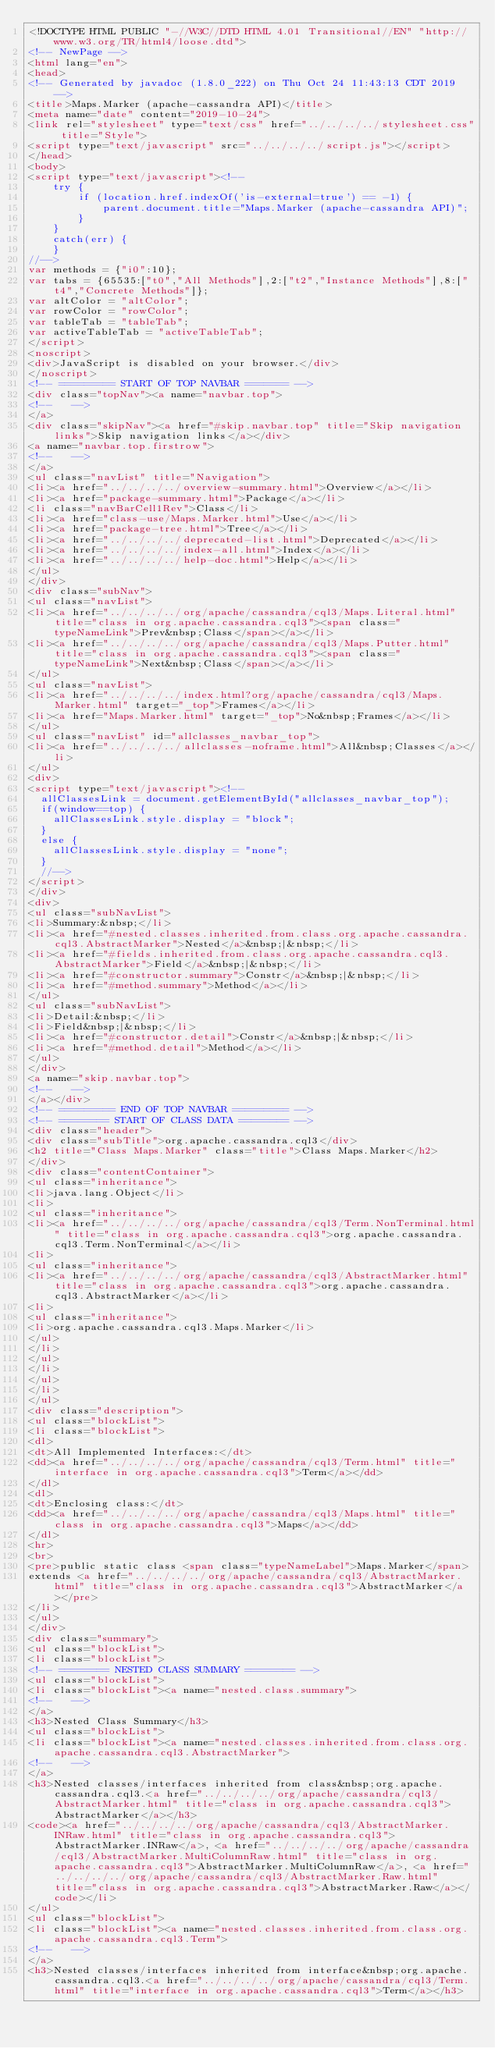Convert code to text. <code><loc_0><loc_0><loc_500><loc_500><_HTML_><!DOCTYPE HTML PUBLIC "-//W3C//DTD HTML 4.01 Transitional//EN" "http://www.w3.org/TR/html4/loose.dtd">
<!-- NewPage -->
<html lang="en">
<head>
<!-- Generated by javadoc (1.8.0_222) on Thu Oct 24 11:43:13 CDT 2019 -->
<title>Maps.Marker (apache-cassandra API)</title>
<meta name="date" content="2019-10-24">
<link rel="stylesheet" type="text/css" href="../../../../stylesheet.css" title="Style">
<script type="text/javascript" src="../../../../script.js"></script>
</head>
<body>
<script type="text/javascript"><!--
    try {
        if (location.href.indexOf('is-external=true') == -1) {
            parent.document.title="Maps.Marker (apache-cassandra API)";
        }
    }
    catch(err) {
    }
//-->
var methods = {"i0":10};
var tabs = {65535:["t0","All Methods"],2:["t2","Instance Methods"],8:["t4","Concrete Methods"]};
var altColor = "altColor";
var rowColor = "rowColor";
var tableTab = "tableTab";
var activeTableTab = "activeTableTab";
</script>
<noscript>
<div>JavaScript is disabled on your browser.</div>
</noscript>
<!-- ========= START OF TOP NAVBAR ======= -->
<div class="topNav"><a name="navbar.top">
<!--   -->
</a>
<div class="skipNav"><a href="#skip.navbar.top" title="Skip navigation links">Skip navigation links</a></div>
<a name="navbar.top.firstrow">
<!--   -->
</a>
<ul class="navList" title="Navigation">
<li><a href="../../../../overview-summary.html">Overview</a></li>
<li><a href="package-summary.html">Package</a></li>
<li class="navBarCell1Rev">Class</li>
<li><a href="class-use/Maps.Marker.html">Use</a></li>
<li><a href="package-tree.html">Tree</a></li>
<li><a href="../../../../deprecated-list.html">Deprecated</a></li>
<li><a href="../../../../index-all.html">Index</a></li>
<li><a href="../../../../help-doc.html">Help</a></li>
</ul>
</div>
<div class="subNav">
<ul class="navList">
<li><a href="../../../../org/apache/cassandra/cql3/Maps.Literal.html" title="class in org.apache.cassandra.cql3"><span class="typeNameLink">Prev&nbsp;Class</span></a></li>
<li><a href="../../../../org/apache/cassandra/cql3/Maps.Putter.html" title="class in org.apache.cassandra.cql3"><span class="typeNameLink">Next&nbsp;Class</span></a></li>
</ul>
<ul class="navList">
<li><a href="../../../../index.html?org/apache/cassandra/cql3/Maps.Marker.html" target="_top">Frames</a></li>
<li><a href="Maps.Marker.html" target="_top">No&nbsp;Frames</a></li>
</ul>
<ul class="navList" id="allclasses_navbar_top">
<li><a href="../../../../allclasses-noframe.html">All&nbsp;Classes</a></li>
</ul>
<div>
<script type="text/javascript"><!--
  allClassesLink = document.getElementById("allclasses_navbar_top");
  if(window==top) {
    allClassesLink.style.display = "block";
  }
  else {
    allClassesLink.style.display = "none";
  }
  //-->
</script>
</div>
<div>
<ul class="subNavList">
<li>Summary:&nbsp;</li>
<li><a href="#nested.classes.inherited.from.class.org.apache.cassandra.cql3.AbstractMarker">Nested</a>&nbsp;|&nbsp;</li>
<li><a href="#fields.inherited.from.class.org.apache.cassandra.cql3.AbstractMarker">Field</a>&nbsp;|&nbsp;</li>
<li><a href="#constructor.summary">Constr</a>&nbsp;|&nbsp;</li>
<li><a href="#method.summary">Method</a></li>
</ul>
<ul class="subNavList">
<li>Detail:&nbsp;</li>
<li>Field&nbsp;|&nbsp;</li>
<li><a href="#constructor.detail">Constr</a>&nbsp;|&nbsp;</li>
<li><a href="#method.detail">Method</a></li>
</ul>
</div>
<a name="skip.navbar.top">
<!--   -->
</a></div>
<!-- ========= END OF TOP NAVBAR ========= -->
<!-- ======== START OF CLASS DATA ======== -->
<div class="header">
<div class="subTitle">org.apache.cassandra.cql3</div>
<h2 title="Class Maps.Marker" class="title">Class Maps.Marker</h2>
</div>
<div class="contentContainer">
<ul class="inheritance">
<li>java.lang.Object</li>
<li>
<ul class="inheritance">
<li><a href="../../../../org/apache/cassandra/cql3/Term.NonTerminal.html" title="class in org.apache.cassandra.cql3">org.apache.cassandra.cql3.Term.NonTerminal</a></li>
<li>
<ul class="inheritance">
<li><a href="../../../../org/apache/cassandra/cql3/AbstractMarker.html" title="class in org.apache.cassandra.cql3">org.apache.cassandra.cql3.AbstractMarker</a></li>
<li>
<ul class="inheritance">
<li>org.apache.cassandra.cql3.Maps.Marker</li>
</ul>
</li>
</ul>
</li>
</ul>
</li>
</ul>
<div class="description">
<ul class="blockList">
<li class="blockList">
<dl>
<dt>All Implemented Interfaces:</dt>
<dd><a href="../../../../org/apache/cassandra/cql3/Term.html" title="interface in org.apache.cassandra.cql3">Term</a></dd>
</dl>
<dl>
<dt>Enclosing class:</dt>
<dd><a href="../../../../org/apache/cassandra/cql3/Maps.html" title="class in org.apache.cassandra.cql3">Maps</a></dd>
</dl>
<hr>
<br>
<pre>public static class <span class="typeNameLabel">Maps.Marker</span>
extends <a href="../../../../org/apache/cassandra/cql3/AbstractMarker.html" title="class in org.apache.cassandra.cql3">AbstractMarker</a></pre>
</li>
</ul>
</div>
<div class="summary">
<ul class="blockList">
<li class="blockList">
<!-- ======== NESTED CLASS SUMMARY ======== -->
<ul class="blockList">
<li class="blockList"><a name="nested.class.summary">
<!--   -->
</a>
<h3>Nested Class Summary</h3>
<ul class="blockList">
<li class="blockList"><a name="nested.classes.inherited.from.class.org.apache.cassandra.cql3.AbstractMarker">
<!--   -->
</a>
<h3>Nested classes/interfaces inherited from class&nbsp;org.apache.cassandra.cql3.<a href="../../../../org/apache/cassandra/cql3/AbstractMarker.html" title="class in org.apache.cassandra.cql3">AbstractMarker</a></h3>
<code><a href="../../../../org/apache/cassandra/cql3/AbstractMarker.INRaw.html" title="class in org.apache.cassandra.cql3">AbstractMarker.INRaw</a>, <a href="../../../../org/apache/cassandra/cql3/AbstractMarker.MultiColumnRaw.html" title="class in org.apache.cassandra.cql3">AbstractMarker.MultiColumnRaw</a>, <a href="../../../../org/apache/cassandra/cql3/AbstractMarker.Raw.html" title="class in org.apache.cassandra.cql3">AbstractMarker.Raw</a></code></li>
</ul>
<ul class="blockList">
<li class="blockList"><a name="nested.classes.inherited.from.class.org.apache.cassandra.cql3.Term">
<!--   -->
</a>
<h3>Nested classes/interfaces inherited from interface&nbsp;org.apache.cassandra.cql3.<a href="../../../../org/apache/cassandra/cql3/Term.html" title="interface in org.apache.cassandra.cql3">Term</a></h3></code> 